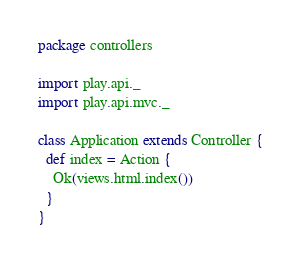Convert code to text. <code><loc_0><loc_0><loc_500><loc_500><_Scala_>package controllers

import play.api._
import play.api.mvc._

class Application extends Controller {
  def index = Action {
    Ok(views.html.index())
  }
}
</code> 